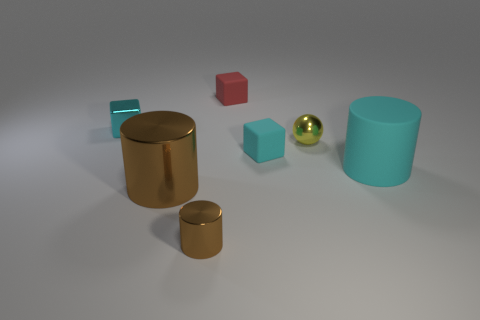Subtract all gray blocks. How many brown cylinders are left? 2 Add 2 small cyan blocks. How many objects exist? 9 Subtract all spheres. How many objects are left? 6 Add 2 red objects. How many red objects exist? 3 Subtract 0 purple blocks. How many objects are left? 7 Subtract all matte objects. Subtract all small cyan cubes. How many objects are left? 2 Add 1 small brown shiny cylinders. How many small brown shiny cylinders are left? 2 